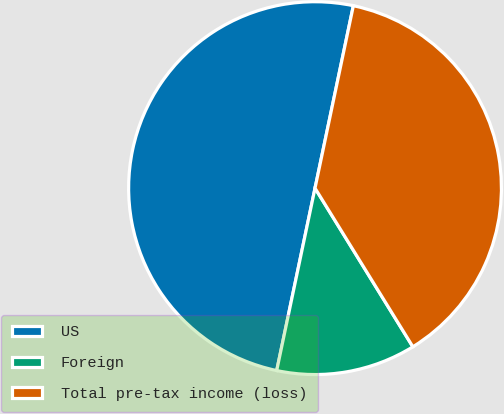Convert chart to OTSL. <chart><loc_0><loc_0><loc_500><loc_500><pie_chart><fcel>US<fcel>Foreign<fcel>Total pre-tax income (loss)<nl><fcel>50.0%<fcel>12.09%<fcel>37.91%<nl></chart> 